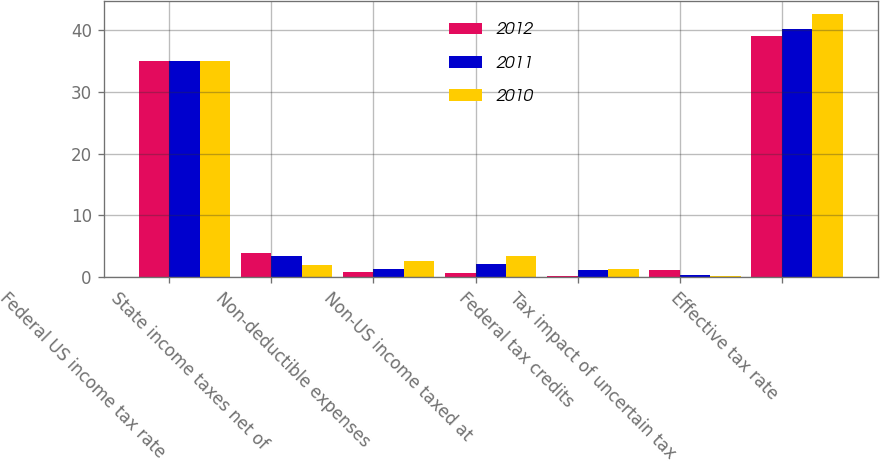<chart> <loc_0><loc_0><loc_500><loc_500><stacked_bar_chart><ecel><fcel>Federal US income tax rate<fcel>State income taxes net of<fcel>Non-deductible expenses<fcel>Non-US income taxed at<fcel>Federal tax credits<fcel>Tax impact of uncertain tax<fcel>Effective tax rate<nl><fcel>2012<fcel>35<fcel>4<fcel>0.8<fcel>0.7<fcel>0.3<fcel>1.2<fcel>39<nl><fcel>2011<fcel>35<fcel>3.4<fcel>1.3<fcel>2.2<fcel>1.2<fcel>0.4<fcel>40.1<nl><fcel>2010<fcel>35<fcel>2<fcel>2.7<fcel>3.4<fcel>1.3<fcel>0.2<fcel>42.6<nl></chart> 